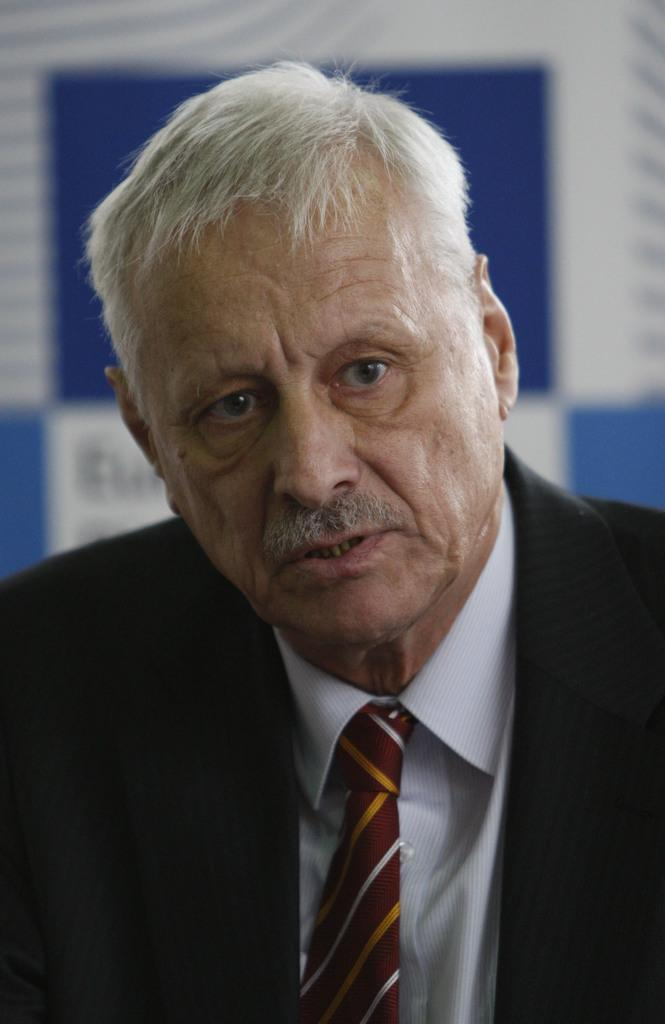Who is present in the image? There is a man in the image. What is the man wearing? The man is wearing a blazer. What can be seen in the background of the image? There is a banner in the background of the image. How many kittens are playing with the wool in the image? There are no kittens or wool present in the image. What type of houses can be seen in the background of the image? There are no houses visible in the image; only a banner is present in the background. 